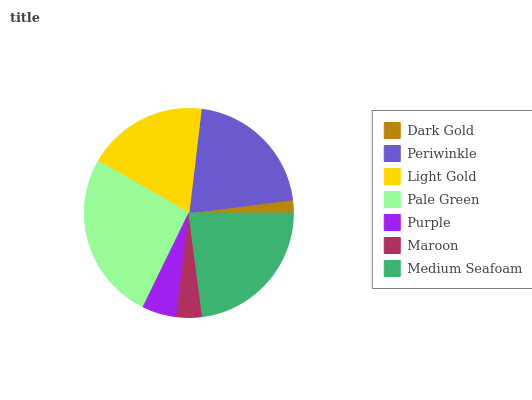Is Dark Gold the minimum?
Answer yes or no. Yes. Is Pale Green the maximum?
Answer yes or no. Yes. Is Periwinkle the minimum?
Answer yes or no. No. Is Periwinkle the maximum?
Answer yes or no. No. Is Periwinkle greater than Dark Gold?
Answer yes or no. Yes. Is Dark Gold less than Periwinkle?
Answer yes or no. Yes. Is Dark Gold greater than Periwinkle?
Answer yes or no. No. Is Periwinkle less than Dark Gold?
Answer yes or no. No. Is Light Gold the high median?
Answer yes or no. Yes. Is Light Gold the low median?
Answer yes or no. Yes. Is Purple the high median?
Answer yes or no. No. Is Pale Green the low median?
Answer yes or no. No. 